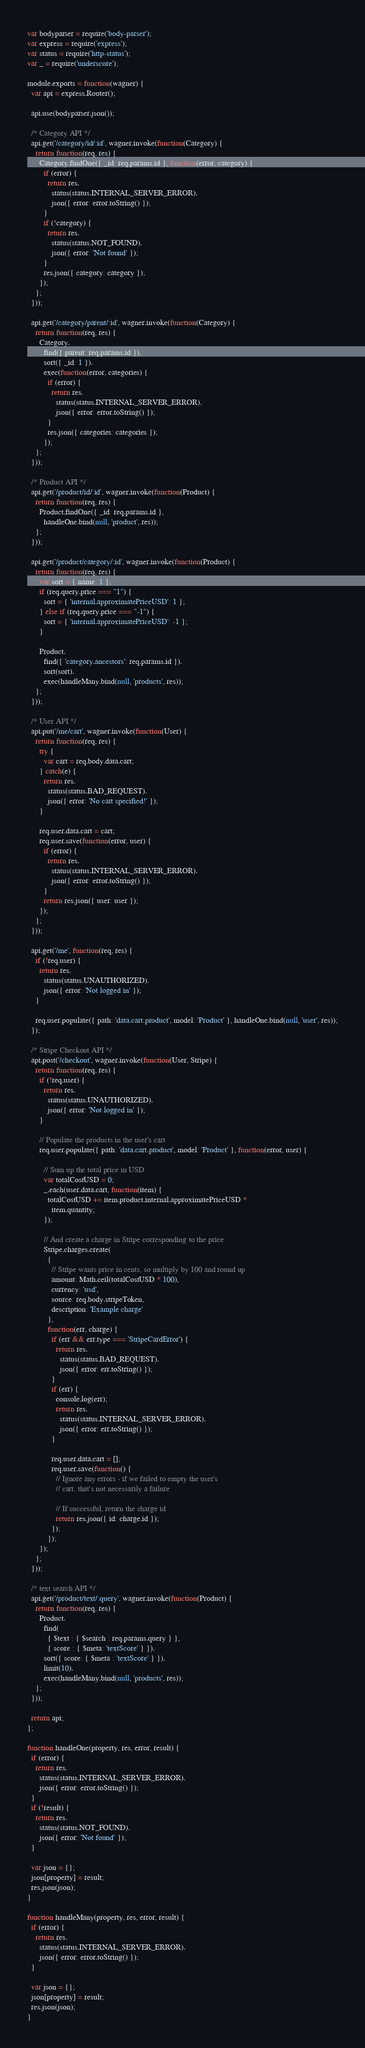<code> <loc_0><loc_0><loc_500><loc_500><_JavaScript_>var bodyparser = require('body-parser');
var express = require('express');
var status = require('http-status');
var _ = require('underscore');

module.exports = function(wagner) {
  var api = express.Router();

  api.use(bodyparser.json());

  /* Category API */
  api.get('/category/id/:id', wagner.invoke(function(Category) {
    return function(req, res) {
      Category.findOne({ _id: req.params.id }, function(error, category) {
        if (error) {
          return res.
            status(status.INTERNAL_SERVER_ERROR).
            json({ error: error.toString() });
        }
        if (!category) {
          return res.
            status(status.NOT_FOUND).
            json({ error: 'Not found' });
        }
        res.json({ category: category });
      });
    };
  }));

  api.get('/category/parent/:id', wagner.invoke(function(Category) {
    return function(req, res) {
      Category.
        find({ parent: req.params.id }).
        sort({ _id: 1 }).
        exec(function(error, categories) {
          if (error) {
            return res.
              status(status.INTERNAL_SERVER_ERROR).
              json({ error: error.toString() });
          }
          res.json({ categories: categories });
        });
    };
  }));

  /* Product API */
  api.get('/product/id/:id', wagner.invoke(function(Product) {
    return function(req, res) {
      Product.findOne({ _id: req.params.id },
        handleOne.bind(null, 'product', res));
    };
  }));

  api.get('/product/category/:id', wagner.invoke(function(Product) {
    return function(req, res) {
      var sort = { name: 1 };
      if (req.query.price === "1") {
        sort = { 'internal.approximatePriceUSD': 1 };
      } else if (req.query.price === "-1") {
        sort = { 'internal.approximatePriceUSD': -1 };
      }

      Product.
        find({ 'category.ancestors': req.params.id }).
        sort(sort).
        exec(handleMany.bind(null, 'products', res));
    };
  }));

  /* User API */
  api.put('/me/cart', wagner.invoke(function(User) {
    return function(req, res) {
      try {
        var cart = req.body.data.cart;
      } catch(e) {
        return res.
          status(status.BAD_REQUEST).
          json({ error: 'No cart specified!' });
      }

      req.user.data.cart = cart;
      req.user.save(function(error, user) {
        if (error) {
          return res.
            status(status.INTERNAL_SERVER_ERROR).
            json({ error: error.toString() });
        }
        return res.json({ user: user });
      });
    };
  }));

  api.get('/me', function(req, res) {
    if (!req.user) {
      return res.
        status(status.UNAUTHORIZED).
        json({ error: 'Not logged in' });
    }

    req.user.populate({ path: 'data.cart.product', model: 'Product' }, handleOne.bind(null, 'user', res));
  });

  /* Stripe Checkout API */
  api.post('/checkout', wagner.invoke(function(User, Stripe) {
    return function(req, res) {
      if (!req.user) {
        return res.
          status(status.UNAUTHORIZED).
          json({ error: 'Not logged in' });
      }

      // Populate the products in the user's cart
      req.user.populate({ path: 'data.cart.product', model: 'Product' }, function(error, user) {

        // Sum up the total price in USD
        var totalCostUSD = 0;
        _.each(user.data.cart, function(item) {
          totalCostUSD += item.product.internal.approximatePriceUSD *
            item.quantity;
        });

        // And create a charge in Stripe corresponding to the price
        Stripe.charges.create(
          {
            // Stripe wants price in cents, so multiply by 100 and round up
            amount: Math.ceil(totalCostUSD * 100),
            currency: 'usd',
            source: req.body.stripeToken,
            description: 'Example charge'
          },
          function(err, charge) {
            if (err && err.type === 'StripeCardError') {
              return res.
                status(status.BAD_REQUEST).
                json({ error: err.toString() });
            }
            if (err) {
              console.log(err);
              return res.
                status(status.INTERNAL_SERVER_ERROR).
                json({ error: err.toString() });
            }

            req.user.data.cart = [];
            req.user.save(function() {
              // Ignore any errors - if we failed to empty the user's
              // cart, that's not necessarily a failure

              // If successful, return the charge id
              return res.json({ id: charge.id });
            });
          });
      });
    };
  }));

  /* text search API */
  api.get('/product/text/:query', wagner.invoke(function(Product) {
    return function(req, res) {
      Product.
        find(
          { $text : { $search : req.params.query } },
          { score : { $meta: 'textScore' } }).
        sort({ score: { $meta : 'textScore' } }).
        limit(10).
        exec(handleMany.bind(null, 'products', res));
    };
  }));

  return api;
};

function handleOne(property, res, error, result) {
  if (error) {
    return res.
      status(status.INTERNAL_SERVER_ERROR).
      json({ error: error.toString() });
  }
  if (!result) {
    return res.
      status(status.NOT_FOUND).
      json({ error: 'Not found' });
  }

  var json = {};
  json[property] = result;
  res.json(json);
}

function handleMany(property, res, error, result) {
  if (error) {
    return res.
      status(status.INTERNAL_SERVER_ERROR).
      json({ error: error.toString() });
  }

  var json = {};
  json[property] = result;
  res.json(json);
}
</code> 